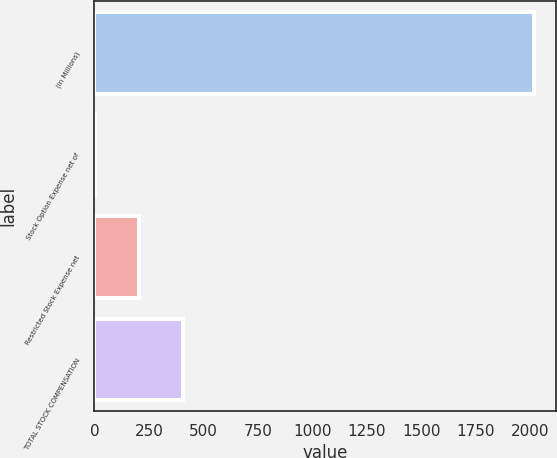Convert chart. <chart><loc_0><loc_0><loc_500><loc_500><bar_chart><fcel>(in Millions)<fcel>Stock Option Expense net of<fcel>Restricted Stock Expense net<fcel>TOTAL STOCK COMPENSATION<nl><fcel>2016<fcel>4.4<fcel>205.56<fcel>406.72<nl></chart> 